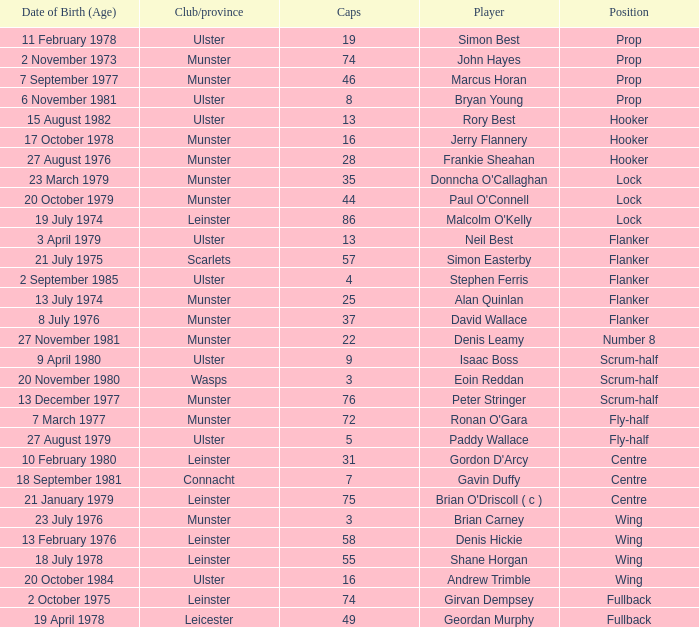Write the full table. {'header': ['Date of Birth (Age)', 'Club/province', 'Caps', 'Player', 'Position'], 'rows': [['11 February 1978', 'Ulster', '19', 'Simon Best', 'Prop'], ['2 November 1973', 'Munster', '74', 'John Hayes', 'Prop'], ['7 September 1977', 'Munster', '46', 'Marcus Horan', 'Prop'], ['6 November 1981', 'Ulster', '8', 'Bryan Young', 'Prop'], ['15 August 1982', 'Ulster', '13', 'Rory Best', 'Hooker'], ['17 October 1978', 'Munster', '16', 'Jerry Flannery', 'Hooker'], ['27 August 1976', 'Munster', '28', 'Frankie Sheahan', 'Hooker'], ['23 March 1979', 'Munster', '35', "Donncha O'Callaghan", 'Lock'], ['20 October 1979', 'Munster', '44', "Paul O'Connell", 'Lock'], ['19 July 1974', 'Leinster', '86', "Malcolm O'Kelly", 'Lock'], ['3 April 1979', 'Ulster', '13', 'Neil Best', 'Flanker'], ['21 July 1975', 'Scarlets', '57', 'Simon Easterby', 'Flanker'], ['2 September 1985', 'Ulster', '4', 'Stephen Ferris', 'Flanker'], ['13 July 1974', 'Munster', '25', 'Alan Quinlan', 'Flanker'], ['8 July 1976', 'Munster', '37', 'David Wallace', 'Flanker'], ['27 November 1981', 'Munster', '22', 'Denis Leamy', 'Number 8'], ['9 April 1980', 'Ulster', '9', 'Isaac Boss', 'Scrum-half'], ['20 November 1980', 'Wasps', '3', 'Eoin Reddan', 'Scrum-half'], ['13 December 1977', 'Munster', '76', 'Peter Stringer', 'Scrum-half'], ['7 March 1977', 'Munster', '72', "Ronan O'Gara", 'Fly-half'], ['27 August 1979', 'Ulster', '5', 'Paddy Wallace', 'Fly-half'], ['10 February 1980', 'Leinster', '31', "Gordon D'Arcy", 'Centre'], ['18 September 1981', 'Connacht', '7', 'Gavin Duffy', 'Centre'], ['21 January 1979', 'Leinster', '75', "Brian O'Driscoll ( c )", 'Centre'], ['23 July 1976', 'Munster', '3', 'Brian Carney', 'Wing'], ['13 February 1976', 'Leinster', '58', 'Denis Hickie', 'Wing'], ['18 July 1978', 'Leinster', '55', 'Shane Horgan', 'Wing'], ['20 October 1984', 'Ulster', '16', 'Andrew Trimble', 'Wing'], ['2 October 1975', 'Leinster', '74', 'Girvan Dempsey', 'Fullback'], ['19 April 1978', 'Leicester', '49', 'Geordan Murphy', 'Fullback']]} Which Ulster player has fewer than 49 caps and plays the wing position? Andrew Trimble. 